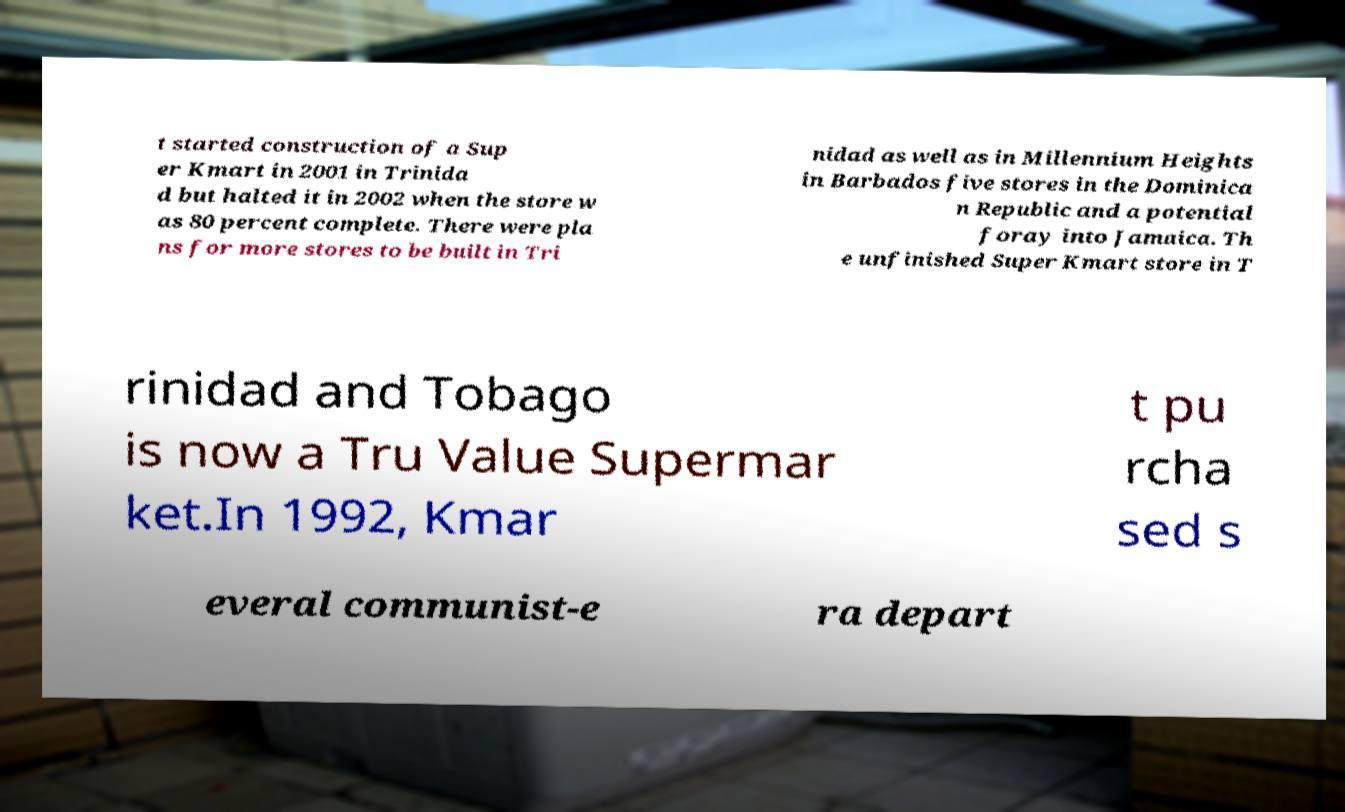There's text embedded in this image that I need extracted. Can you transcribe it verbatim? t started construction of a Sup er Kmart in 2001 in Trinida d but halted it in 2002 when the store w as 80 percent complete. There were pla ns for more stores to be built in Tri nidad as well as in Millennium Heights in Barbados five stores in the Dominica n Republic and a potential foray into Jamaica. Th e unfinished Super Kmart store in T rinidad and Tobago is now a Tru Value Supermar ket.In 1992, Kmar t pu rcha sed s everal communist-e ra depart 